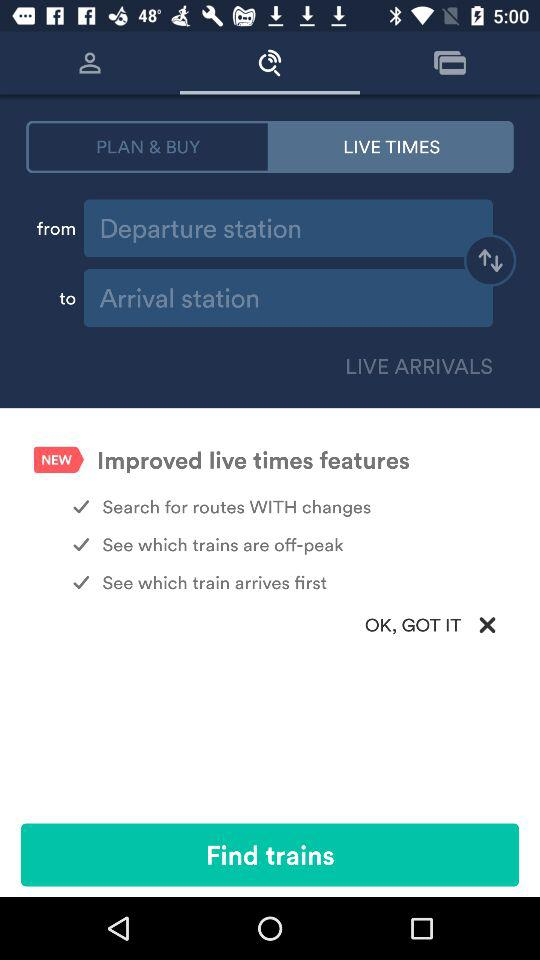How many check marks are there on the screen?
Answer the question using a single word or phrase. 3 